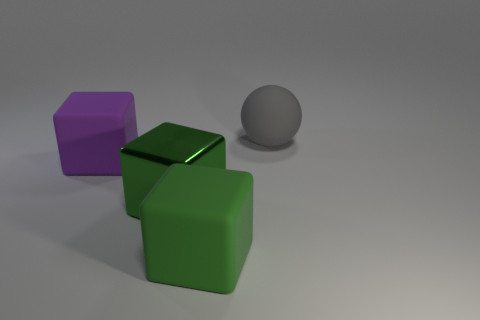What number of rubber objects have the same size as the green metal thing?
Your answer should be compact. 3. There is a rubber object that is the same color as the metallic thing; what is its size?
Your response must be concise. Large. Does the shiny cube have the same color as the large sphere?
Provide a succinct answer. No. There is a green matte thing; what shape is it?
Keep it short and to the point. Cube. Are there any other large metallic objects that have the same color as the metal thing?
Give a very brief answer. No. Are there more cubes right of the purple block than large green things?
Your answer should be compact. No. There is a big gray thing; does it have the same shape as the rubber thing that is in front of the large purple cube?
Provide a succinct answer. No. Are there any large green objects?
Your response must be concise. Yes. What number of big things are either gray things or metal cubes?
Your answer should be compact. 2. Is the number of large green metal objects behind the big metal thing greater than the number of gray rubber spheres in front of the gray ball?
Provide a short and direct response. No. 